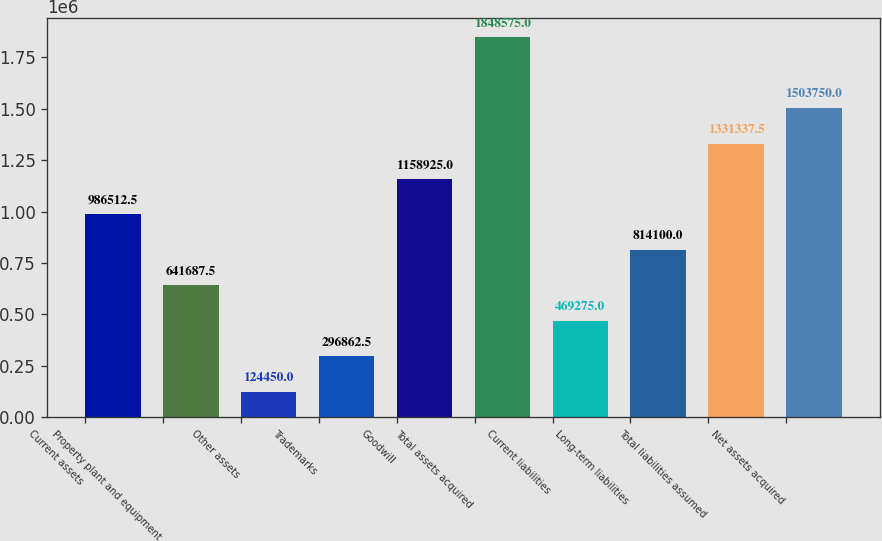Convert chart. <chart><loc_0><loc_0><loc_500><loc_500><bar_chart><fcel>Current assets<fcel>Property plant and equipment<fcel>Other assets<fcel>Trademarks<fcel>Goodwill<fcel>Total assets acquired<fcel>Current liabilities<fcel>Long-term liabilities<fcel>Total liabilities assumed<fcel>Net assets acquired<nl><fcel>986512<fcel>641688<fcel>124450<fcel>296862<fcel>1.15892e+06<fcel>1.84858e+06<fcel>469275<fcel>814100<fcel>1.33134e+06<fcel>1.50375e+06<nl></chart> 